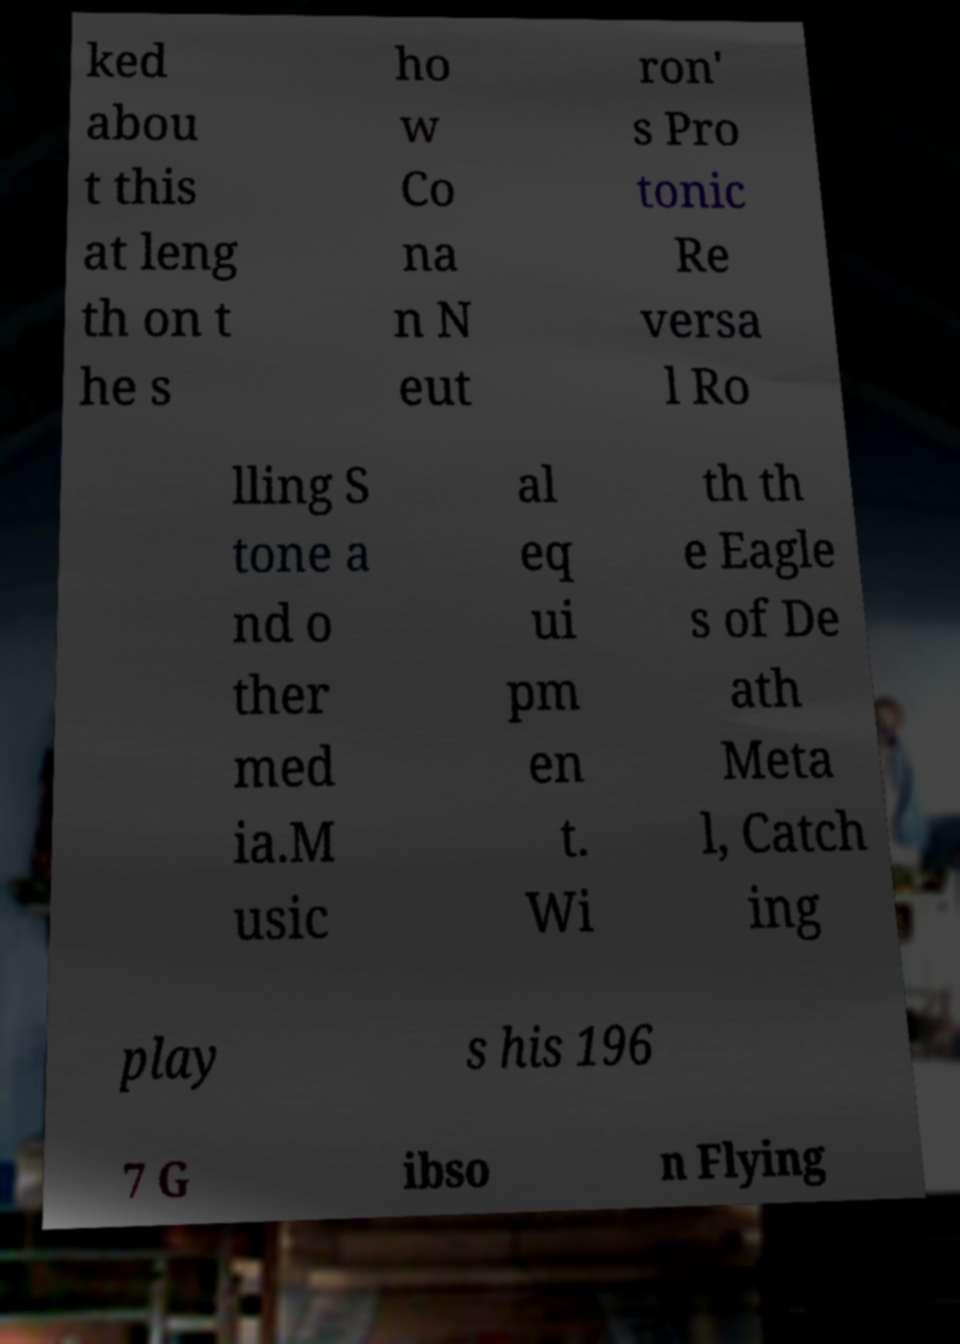Please identify and transcribe the text found in this image. ked abou t this at leng th on t he s ho w Co na n N eut ron' s Pro tonic Re versa l Ro lling S tone a nd o ther med ia.M usic al eq ui pm en t. Wi th th e Eagle s of De ath Meta l, Catch ing play s his 196 7 G ibso n Flying 